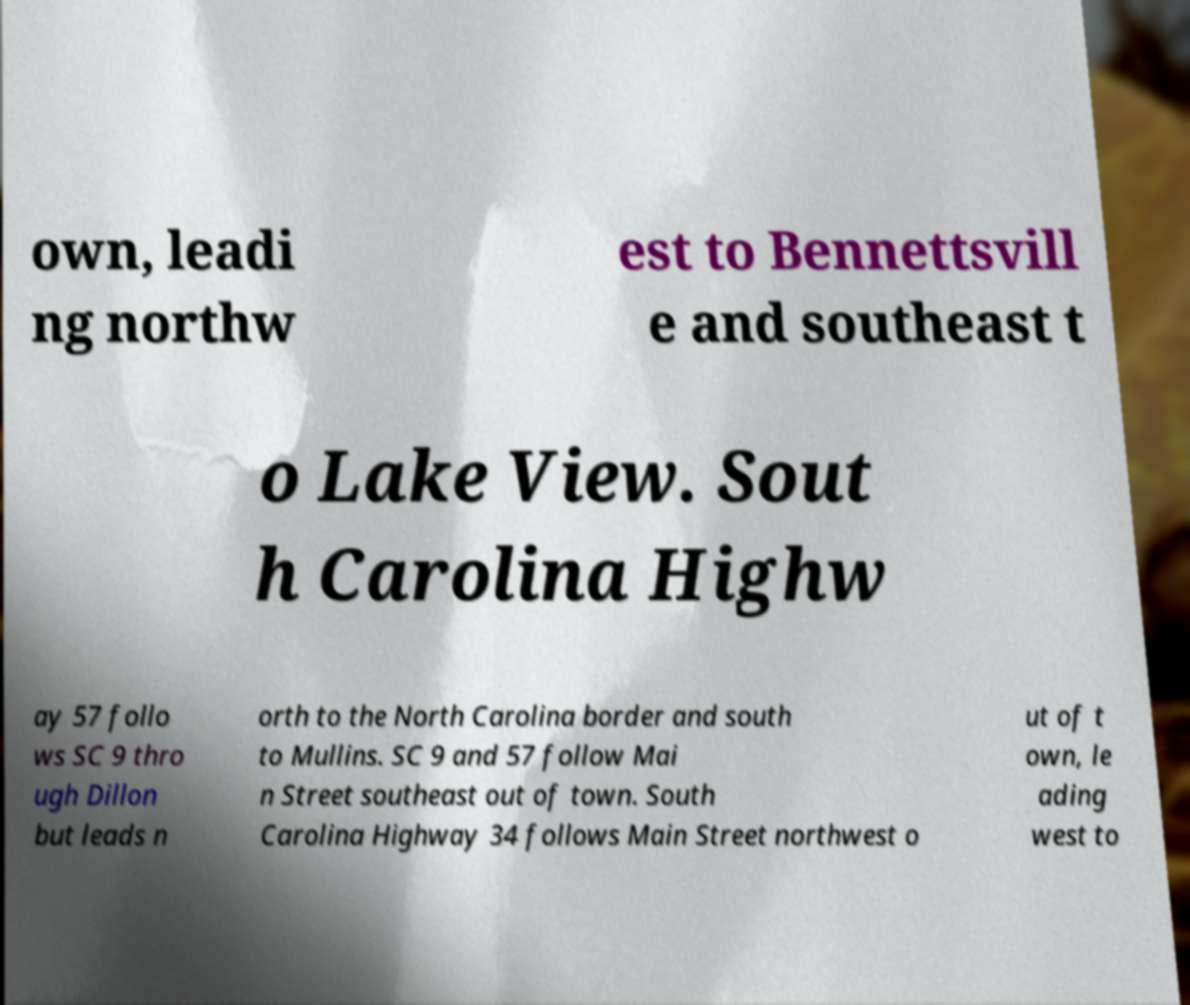Could you extract and type out the text from this image? own, leadi ng northw est to Bennettsvill e and southeast t o Lake View. Sout h Carolina Highw ay 57 follo ws SC 9 thro ugh Dillon but leads n orth to the North Carolina border and south to Mullins. SC 9 and 57 follow Mai n Street southeast out of town. South Carolina Highway 34 follows Main Street northwest o ut of t own, le ading west to 